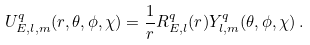<formula> <loc_0><loc_0><loc_500><loc_500>U _ { E , l , m } ^ { q } ( r , \theta , \phi , \chi ) = \frac { 1 } { r } R _ { E , l } ^ { q } ( r ) Y _ { l , m } ^ { q } ( \theta , \phi , \chi ) \, .</formula> 